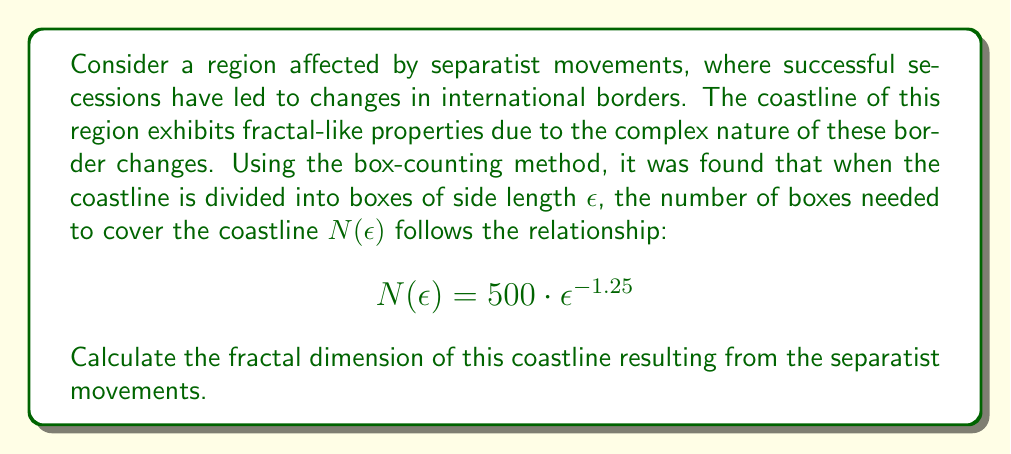Solve this math problem. To calculate the fractal dimension using the box-counting method, we follow these steps:

1) The general form of the box-counting relationship is:

   $$N(\epsilon) = C \cdot \epsilon^{-D}$$

   where $D$ is the fractal dimension we're seeking, and $C$ is a constant.

2) In our case, we have:

   $$N(\epsilon) = 500 \cdot \epsilon^{-1.25}$$

3) Comparing this to the general form, we can see that:

   $C = 500$
   $-D = -1.25$

4) Therefore, the fractal dimension $D$ is simply:

   $$D = 1.25$$

This fractal dimension between 1 and 2 indicates a coastline that is more complex than a smooth line (dimension 1) but does not fill a plane (dimension 2). The value of 1.25 suggests a moderately complex coastline, reflecting the intricate border changes resulting from successful separatist movements.
Answer: $D = 1.25$ 